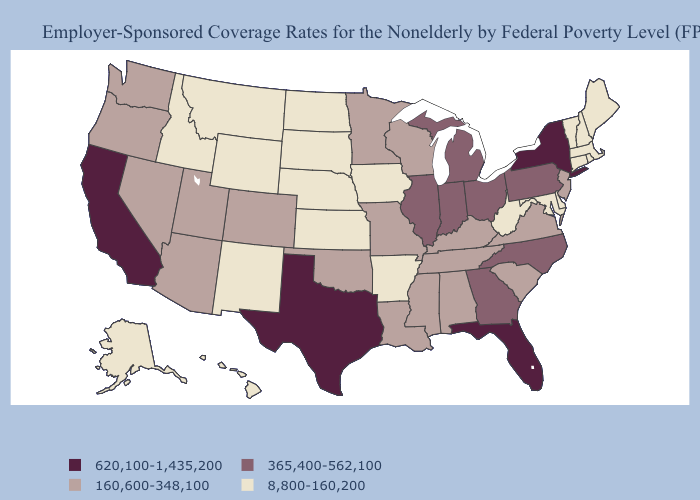What is the value of Tennessee?
Keep it brief. 160,600-348,100. What is the lowest value in states that border Florida?
Keep it brief. 160,600-348,100. What is the lowest value in the West?
Be succinct. 8,800-160,200. Does Kansas have the lowest value in the USA?
Keep it brief. Yes. Which states have the lowest value in the USA?
Short answer required. Alaska, Arkansas, Connecticut, Delaware, Hawaii, Idaho, Iowa, Kansas, Maine, Maryland, Massachusetts, Montana, Nebraska, New Hampshire, New Mexico, North Dakota, Rhode Island, South Dakota, Vermont, West Virginia, Wyoming. Does Illinois have the same value as Ohio?
Concise answer only. Yes. Does Montana have a higher value than Missouri?
Answer briefly. No. What is the value of Nevada?
Give a very brief answer. 160,600-348,100. Which states have the lowest value in the Northeast?
Concise answer only. Connecticut, Maine, Massachusetts, New Hampshire, Rhode Island, Vermont. What is the highest value in states that border Montana?
Keep it brief. 8,800-160,200. What is the value of New Jersey?
Give a very brief answer. 160,600-348,100. What is the value of North Carolina?
Give a very brief answer. 365,400-562,100. Name the states that have a value in the range 365,400-562,100?
Short answer required. Georgia, Illinois, Indiana, Michigan, North Carolina, Ohio, Pennsylvania. Does California have the highest value in the USA?
Write a very short answer. Yes. What is the value of Oregon?
Give a very brief answer. 160,600-348,100. 